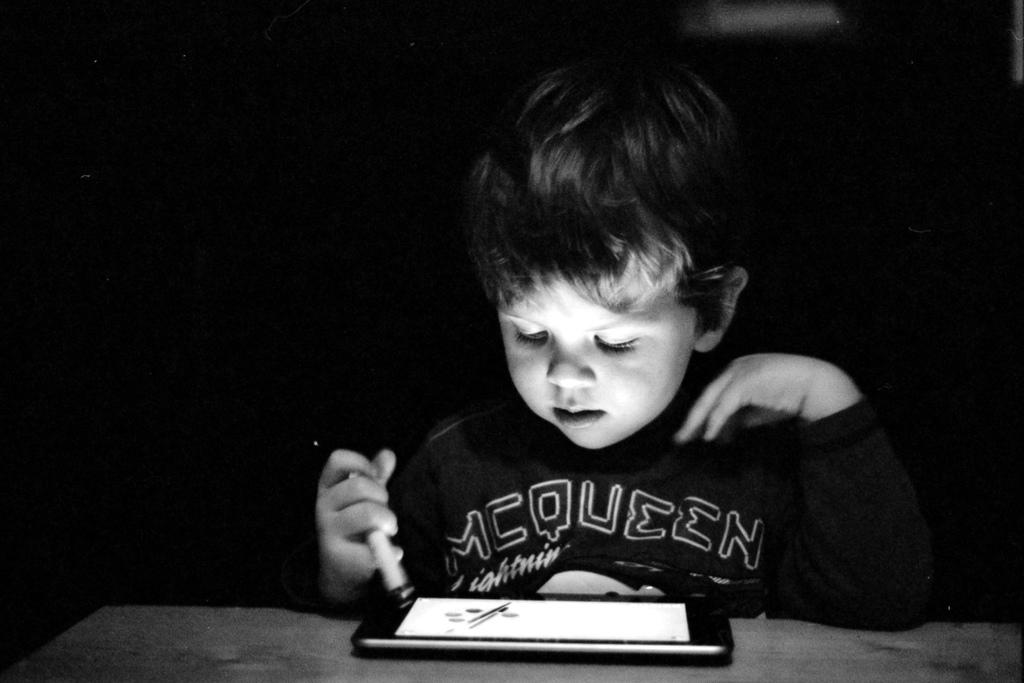What is the main subject of the image? The main subject of the image is a boy. What is the boy doing in the image? The boy is sitting in the image. What is the boy looking at while sitting? The boy is looking at a smartphone. What type of brush is the boy using to create a painting in the image? There is no brush or painting present in the image; the boy is looking at a smartphone. 